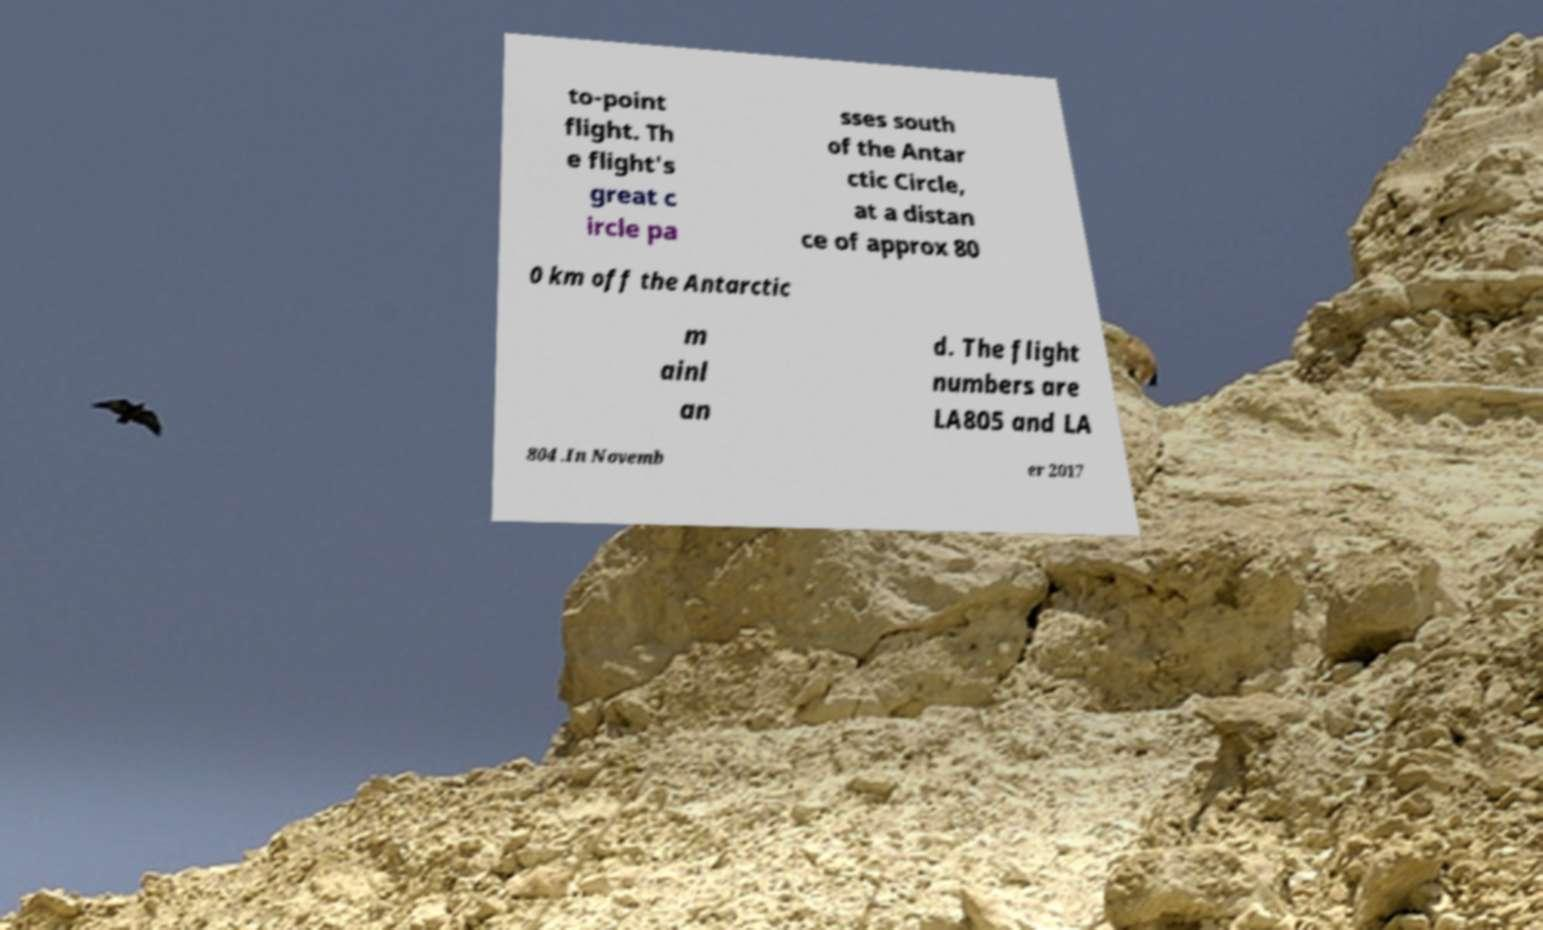Could you extract and type out the text from this image? to-point flight. Th e flight's great c ircle pa sses south of the Antar ctic Circle, at a distan ce of approx 80 0 km off the Antarctic m ainl an d. The flight numbers are LA805 and LA 804 .In Novemb er 2017 